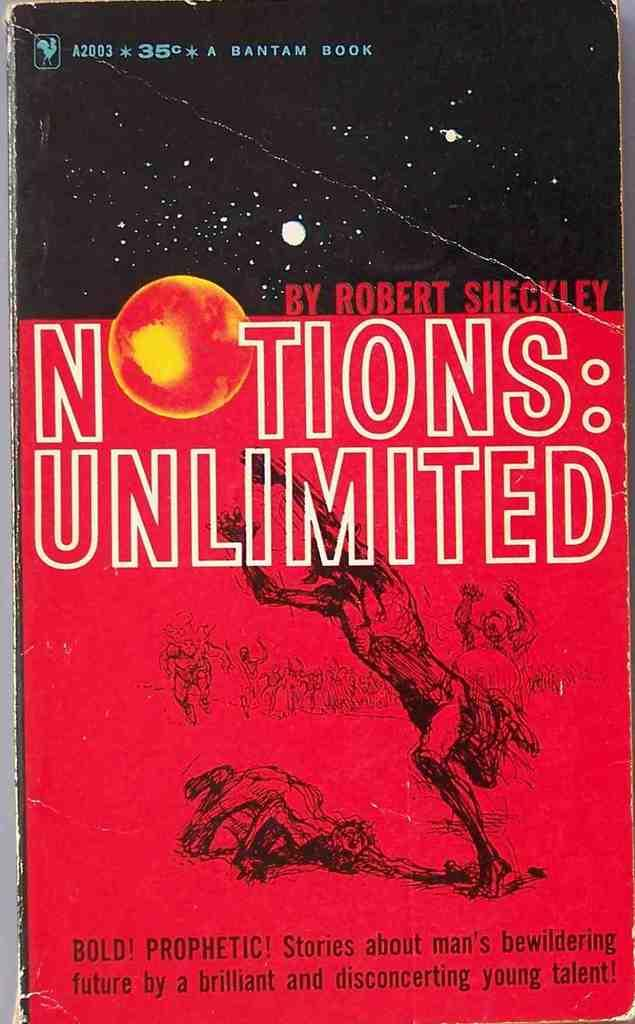<image>
Provide a brief description of the given image. A book that has Notions Unlimited on it 